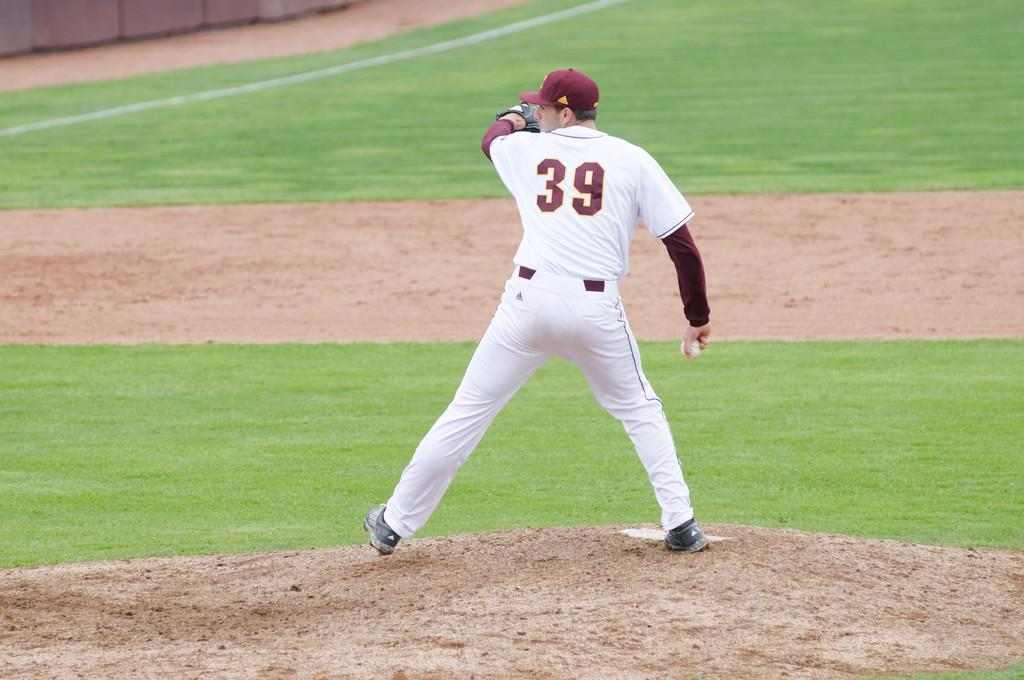What is the main subject of the image? There is a man standing in the center of the image. What can be seen in the background of the image? There is grass on the ground in the background of the image. What color is the rose on the man's lapel in the image? There is no rose present on the man's lapel in the image. Where is the gold statue located in the image? There is no gold statue present in the image. 